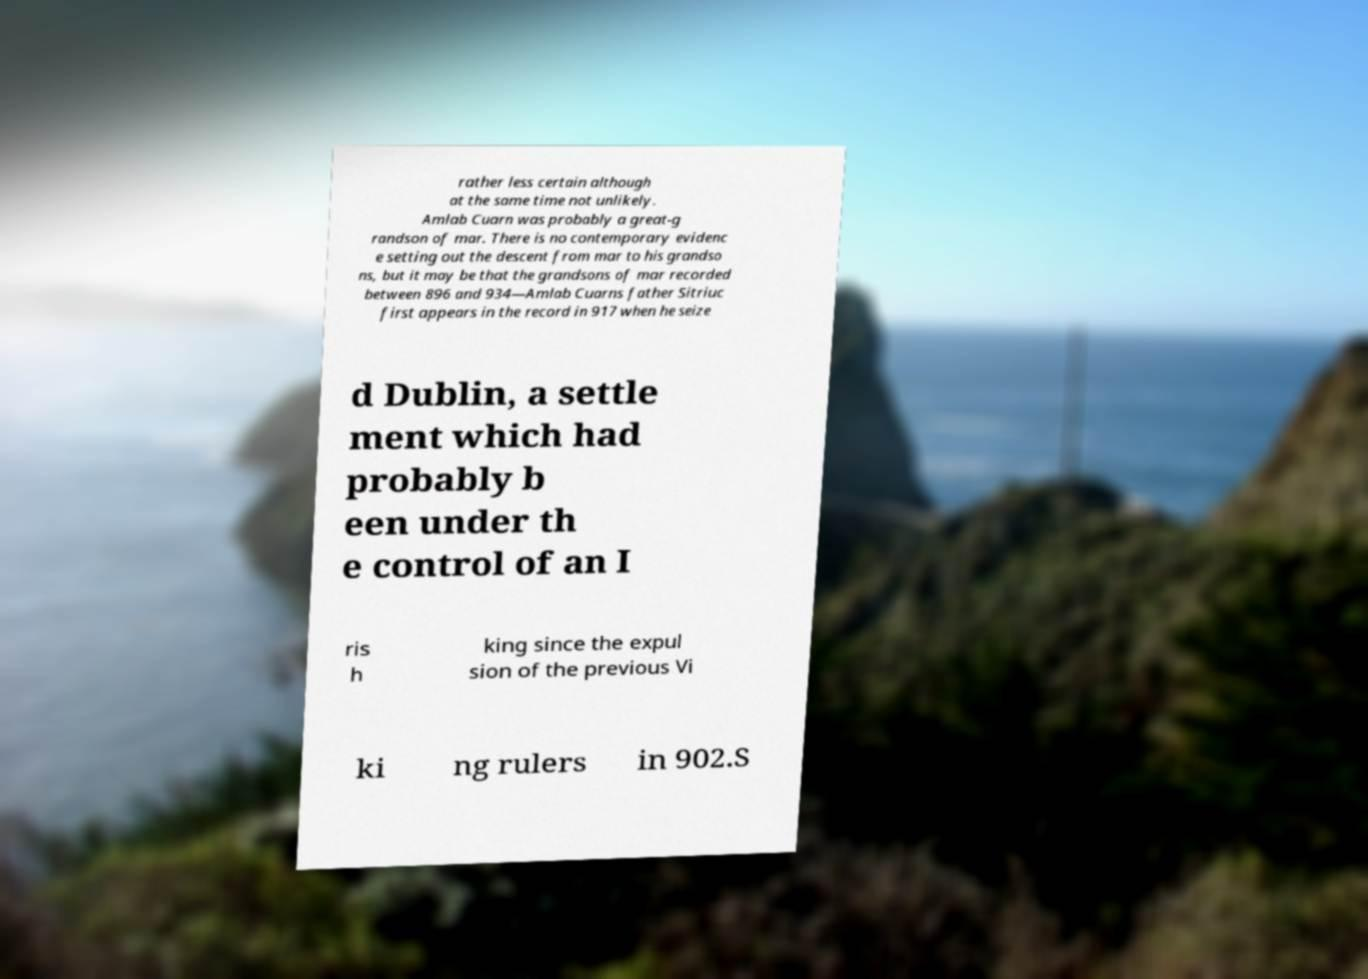Can you accurately transcribe the text from the provided image for me? rather less certain although at the same time not unlikely. Amlab Cuarn was probably a great-g randson of mar. There is no contemporary evidenc e setting out the descent from mar to his grandso ns, but it may be that the grandsons of mar recorded between 896 and 934—Amlab Cuarns father Sitriuc first appears in the record in 917 when he seize d Dublin, a settle ment which had probably b een under th e control of an I ris h king since the expul sion of the previous Vi ki ng rulers in 902.S 